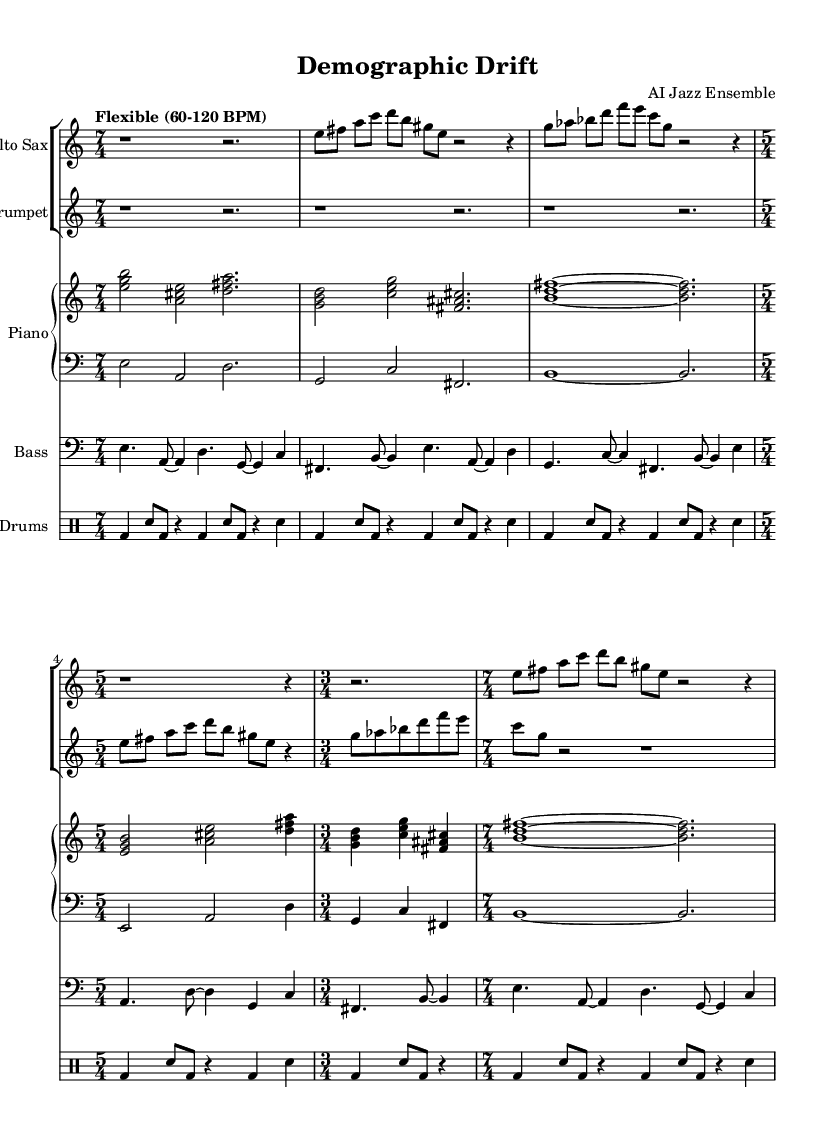What is the key signature of this music? The key signature is C major, indicated by the absence of sharps or flats in the key signature section. This can be verified by checking the key signature at the beginning of the staff.
Answer: C major What is the time signature of the first section? The first section of the piece is in 7/4 time, which is shown clearly at the start of the music. It indicates that there are seven beats per measure.
Answer: 7/4 What tempo marking is indicated? The tempo marking is "Flexible (60-120 BPM)", which is specified at the beginning of the score indicating a range for the performance speed.
Answer: Flexible (60-120 BPM) How many measures are in 5/4 time? There are 2 measures in 5/4 time, which can be identified by locating the 5/4 time signature in the music and counting the measures that follow it.
Answer: 2 Which instrument plays the solo in the first section? The alto saxophone plays the solo in the first section, as it has the primary musical lines during the initial measures.
Answer: Alto Sax What rhythmic pattern does the drums follow in the 3/4 section? The drums follow a pattern of bass drum and snare hits, indicated in the drumming notation during the 3/4 section, showing a consistent backbeat.
Answer: Bass and snare Which instruments play in harmony during the piano section? The piano section has a right hand and left hand playing in harmony, with chords and bass notes combining. This can be noted by their simultaneous presence on the staff.
Answer: Piano 